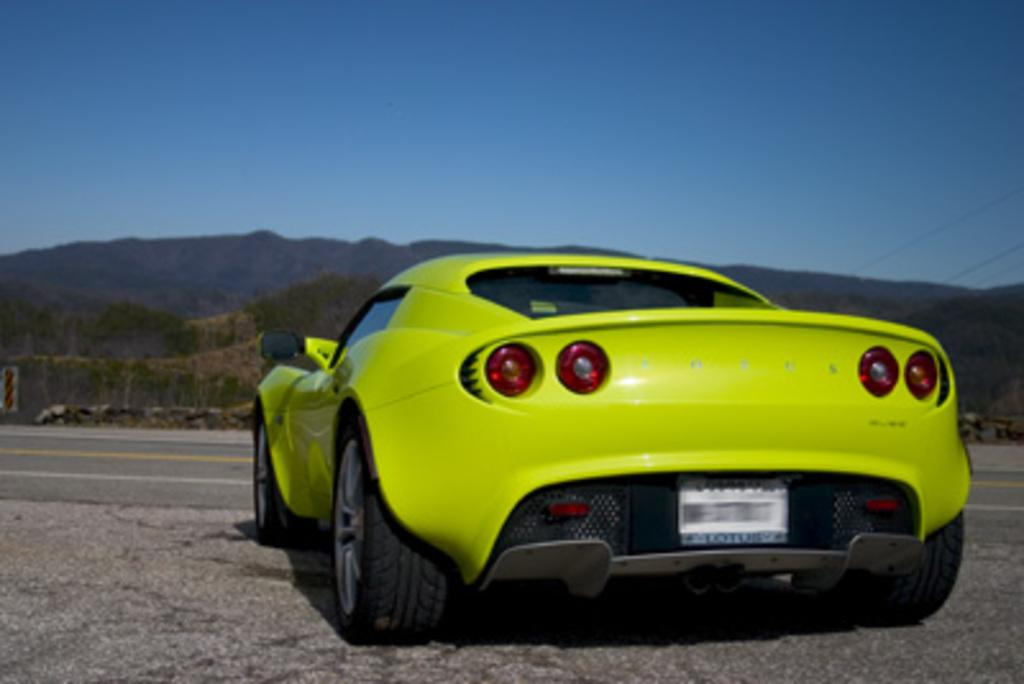What type of vehicle is in the image? There is a sports car in the image. What natural feature can be seen in the background of the image? Mountains are visible in the image. What type of quiver is visible in the image? There is no quiver present in the image. How many grapes are on the sports car in the image? There are no grapes present in the image. 